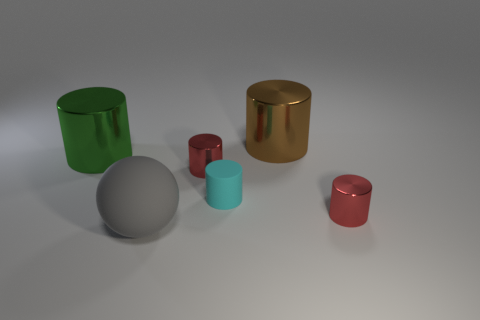There is a metal object on the left side of the big gray sphere; is its color the same as the metallic cylinder that is behind the green shiny cylinder?
Provide a short and direct response. No. What number of objects are both in front of the cyan matte cylinder and left of the big brown thing?
Provide a short and direct response. 1. What is the size of the cyan thing that is made of the same material as the ball?
Your response must be concise. Small. The cyan cylinder is what size?
Provide a succinct answer. Small. What is the large sphere made of?
Your answer should be compact. Rubber. There is a matte object behind the sphere; is it the same size as the green object?
Provide a succinct answer. No. How many things are rubber objects or large gray matte objects?
Provide a succinct answer. 2. There is a object that is both in front of the green object and behind the cyan rubber cylinder; what size is it?
Your response must be concise. Small. What number of small red metallic cylinders are there?
Give a very brief answer. 2. How many balls are either metal things or big gray things?
Offer a very short reply. 1. 